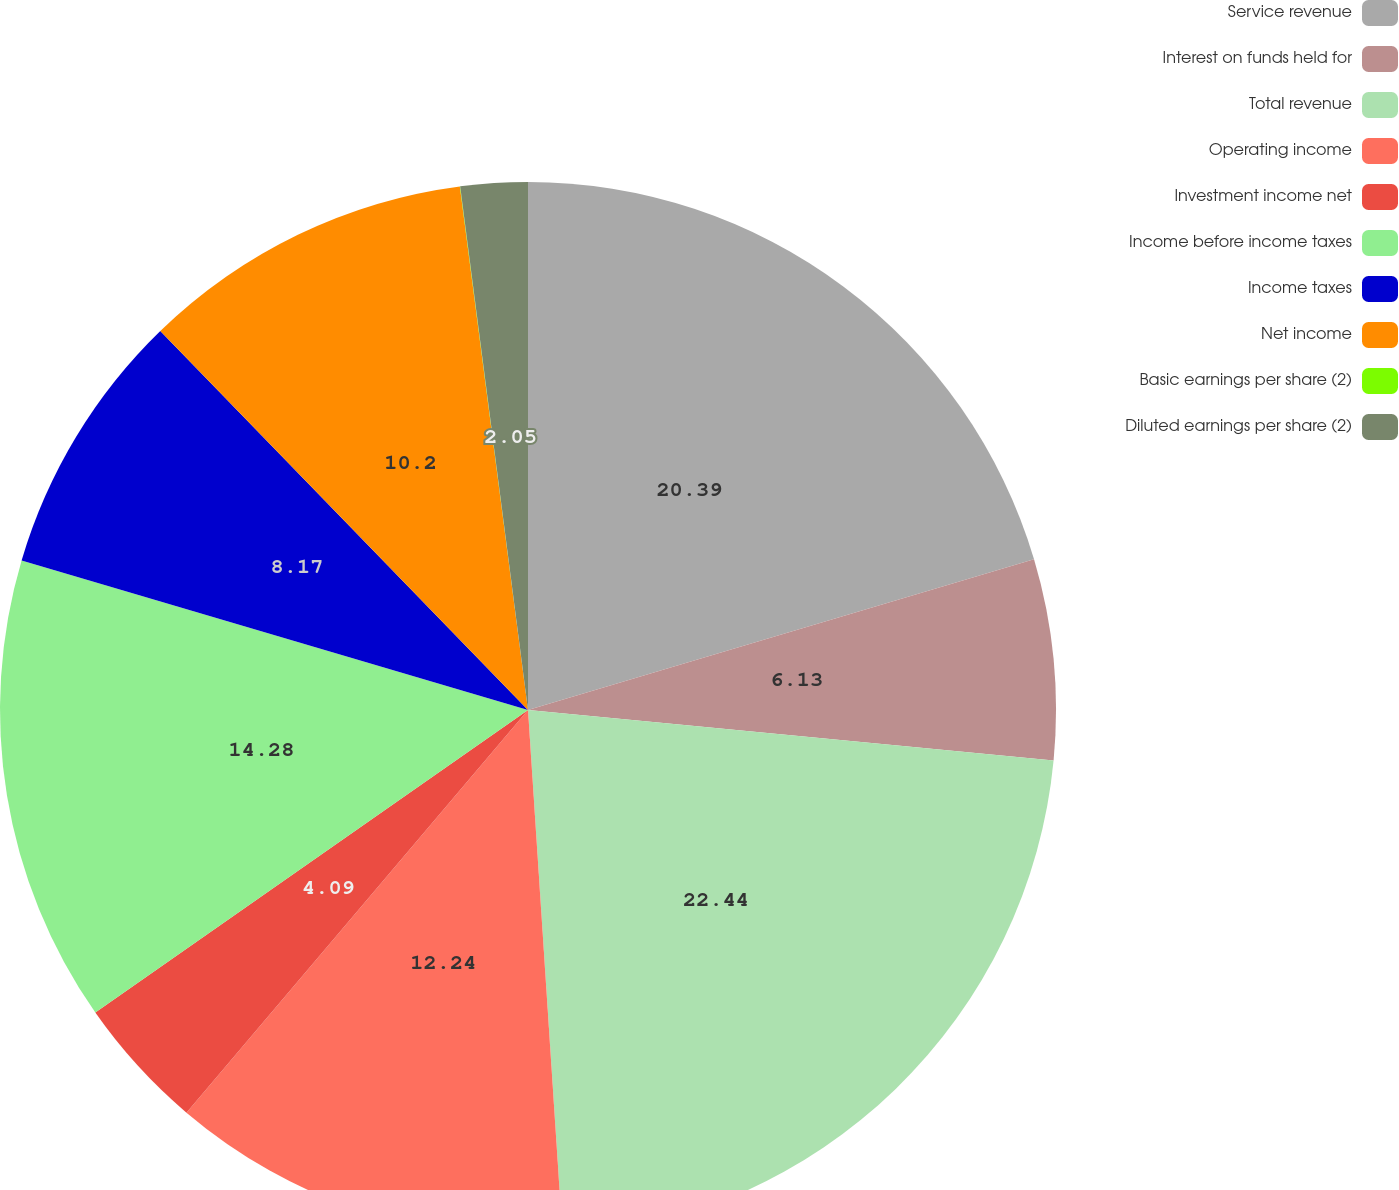Convert chart to OTSL. <chart><loc_0><loc_0><loc_500><loc_500><pie_chart><fcel>Service revenue<fcel>Interest on funds held for<fcel>Total revenue<fcel>Operating income<fcel>Investment income net<fcel>Income before income taxes<fcel>Income taxes<fcel>Net income<fcel>Basic earnings per share (2)<fcel>Diluted earnings per share (2)<nl><fcel>20.39%<fcel>6.13%<fcel>22.43%<fcel>12.24%<fcel>4.09%<fcel>14.28%<fcel>8.17%<fcel>10.2%<fcel>0.01%<fcel>2.05%<nl></chart> 